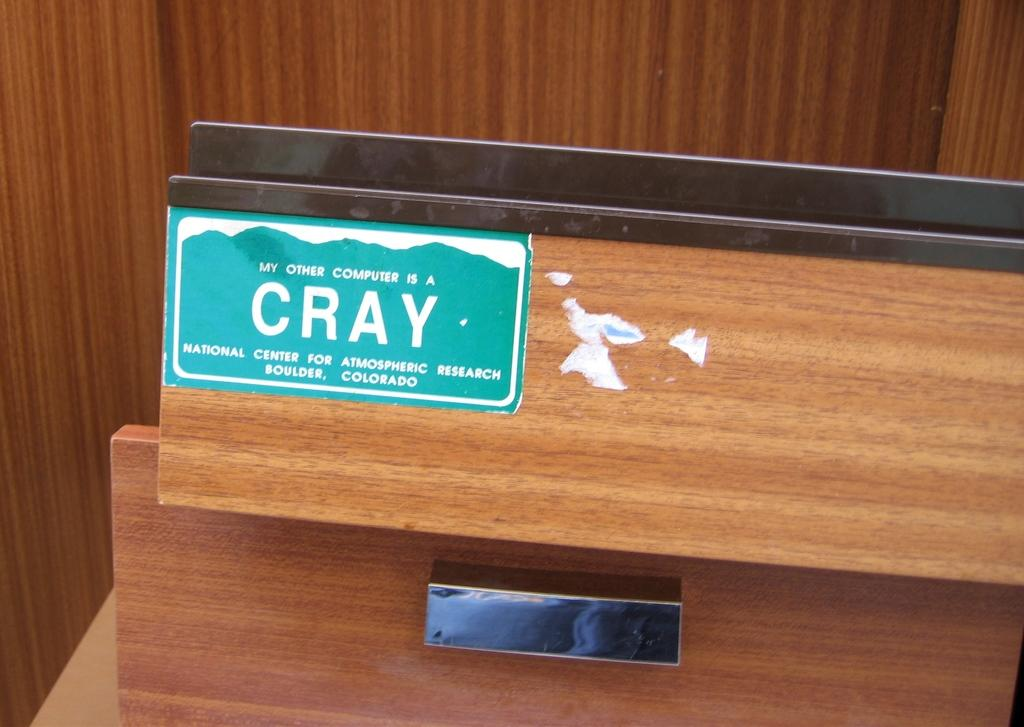What is on the wooden surface in the image? There is a poster with text on the wooden surface in the image. Are there any other objects or features on the wooden surface? Yes, there are two metal strips on the wooden surface. What can be seen in the background of the image? There is a wooden wall in the background of the image. How many ants can be seen crawling on the poster in the image? There are no ants present in the image; it only features a poster with text on a wooden surface, two metal strips, and a wooden wall in the background. 